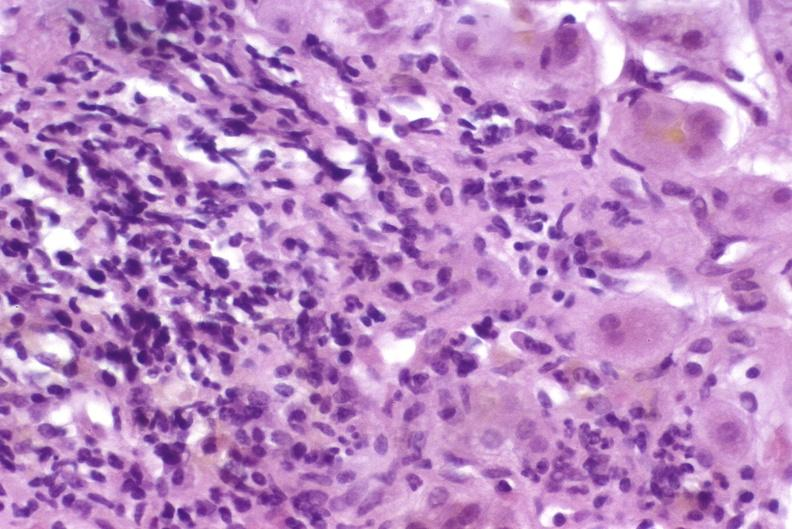what does this image show?
Answer the question using a single word or phrase. Autoimmune hepatitis 